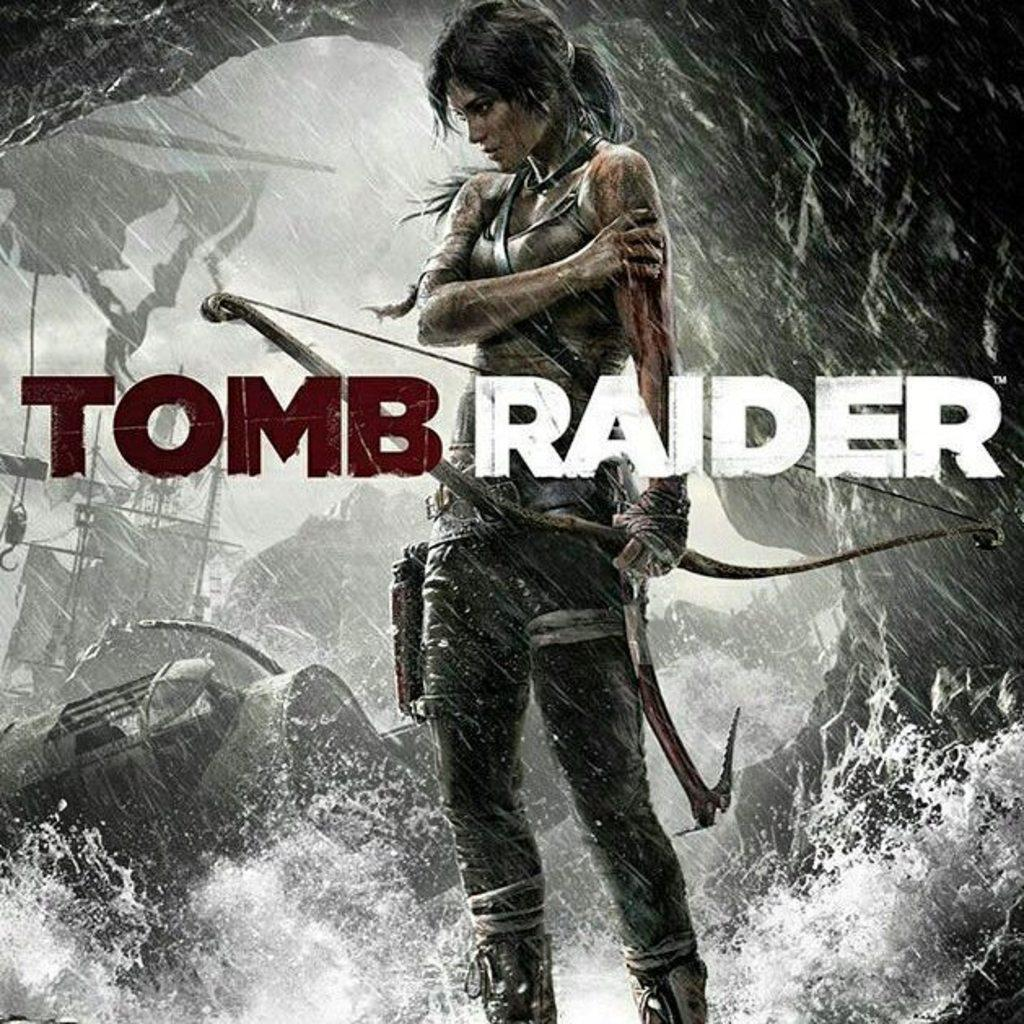<image>
Share a concise interpretation of the image provided. A poster for the video game Tomb Raider showing a woman with a bow standing in a cave full of rushing water. 